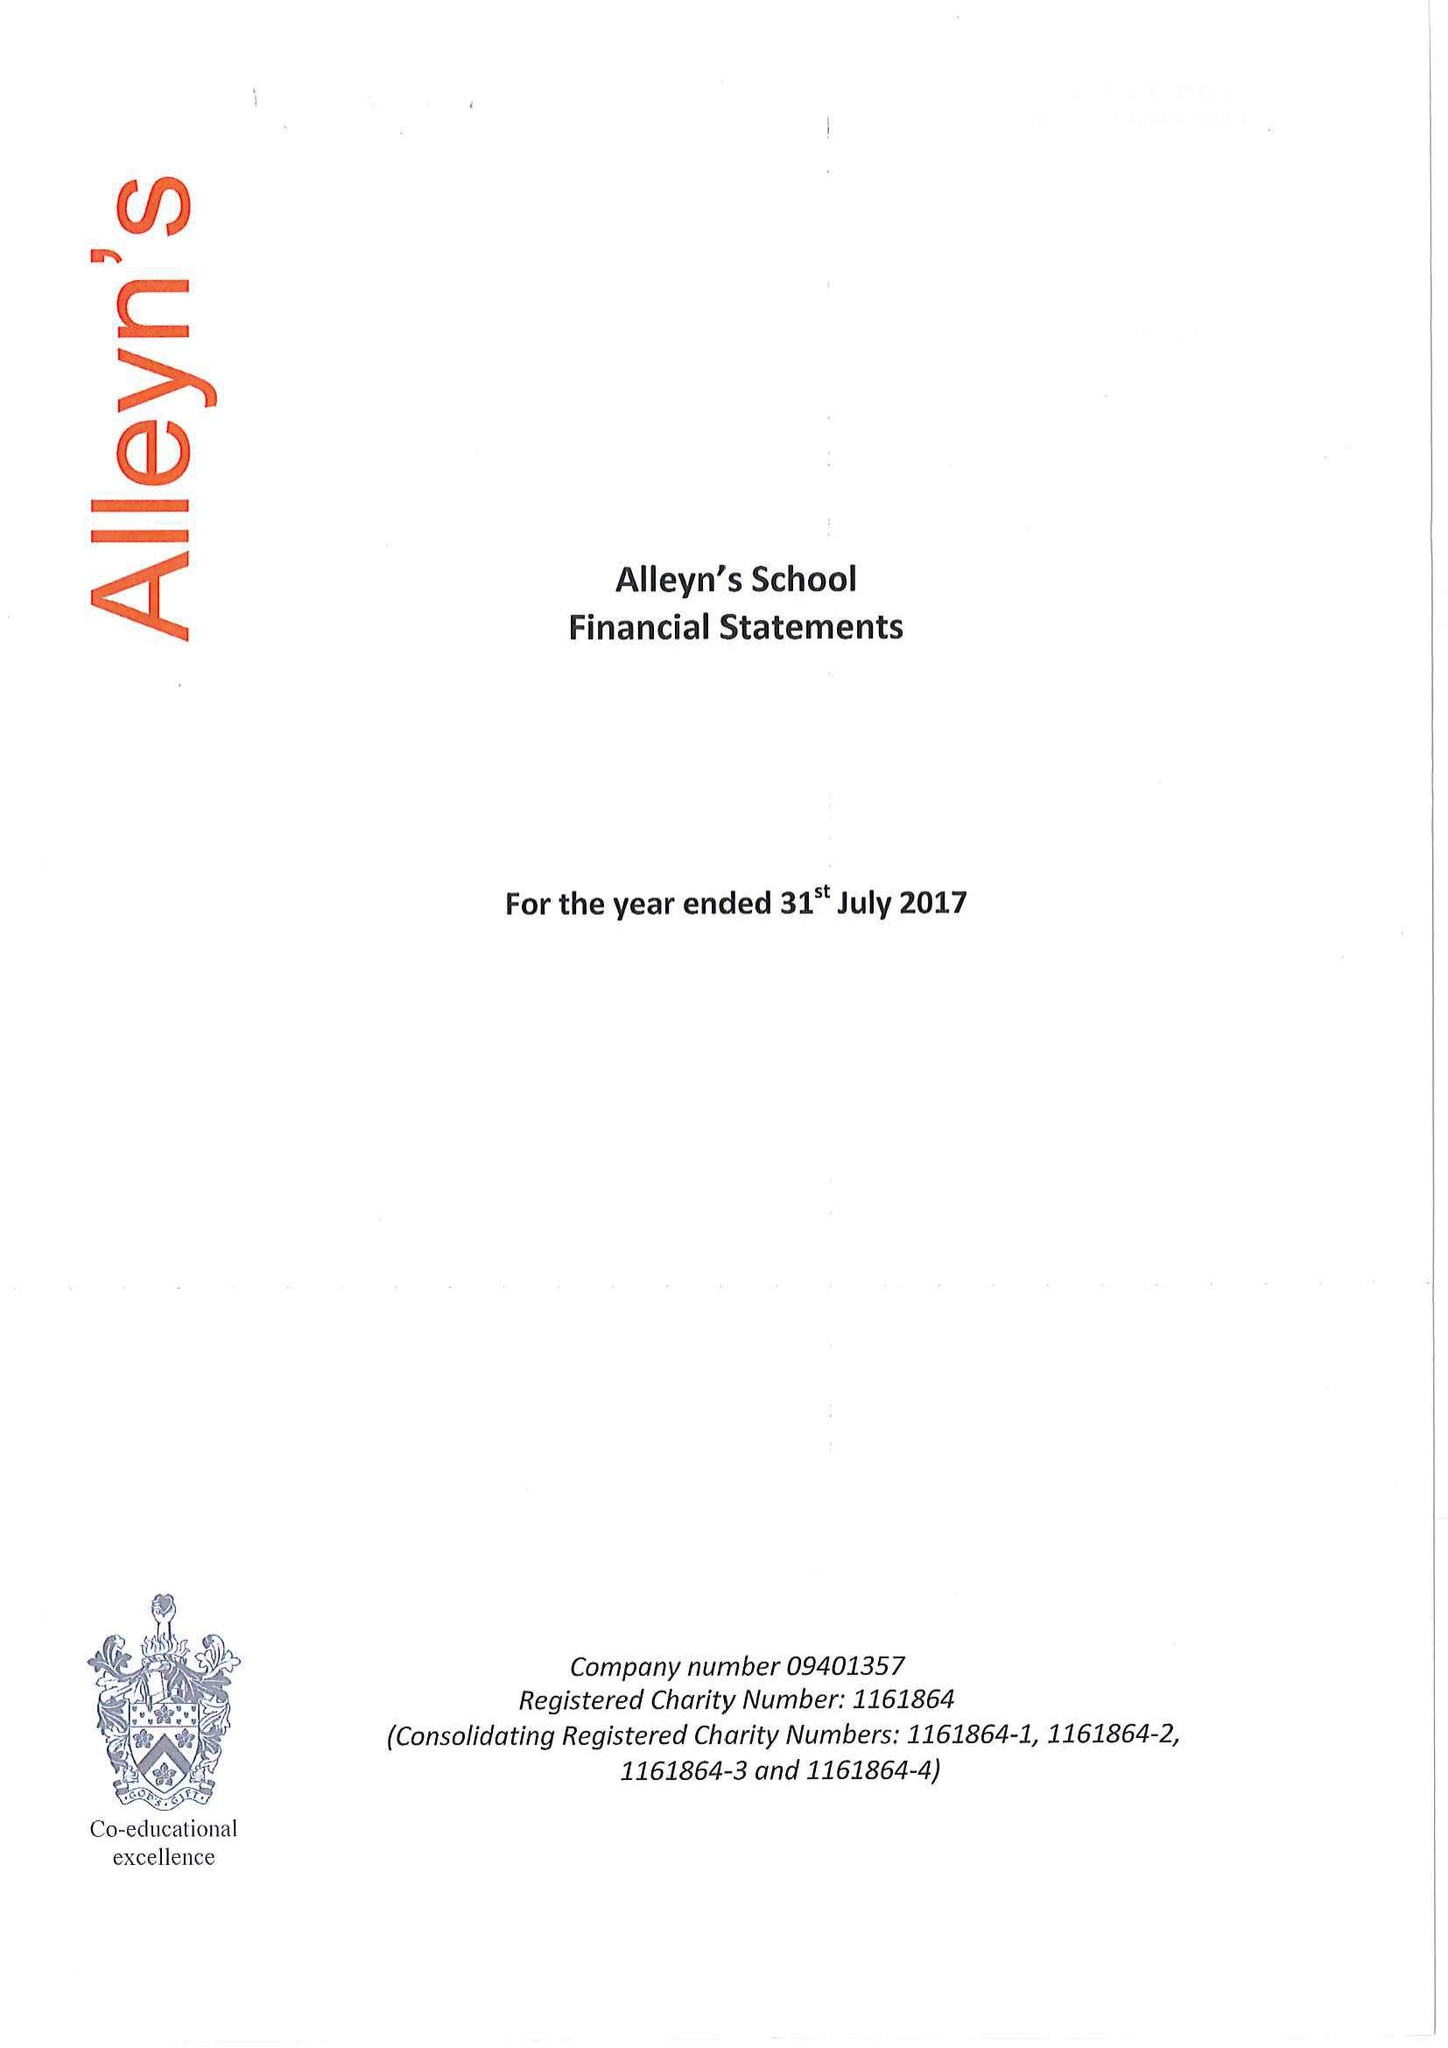What is the value for the address__postcode?
Answer the question using a single word or phrase. SE22 8SU 